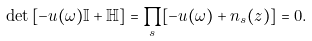Convert formula to latex. <formula><loc_0><loc_0><loc_500><loc_500>\det { [ - u ( \omega ) { \mathbb { I } } + \mathbb { H } ] } = \prod _ { s } [ - u ( \omega ) + n _ { s } ( z ) ] = 0 .</formula> 